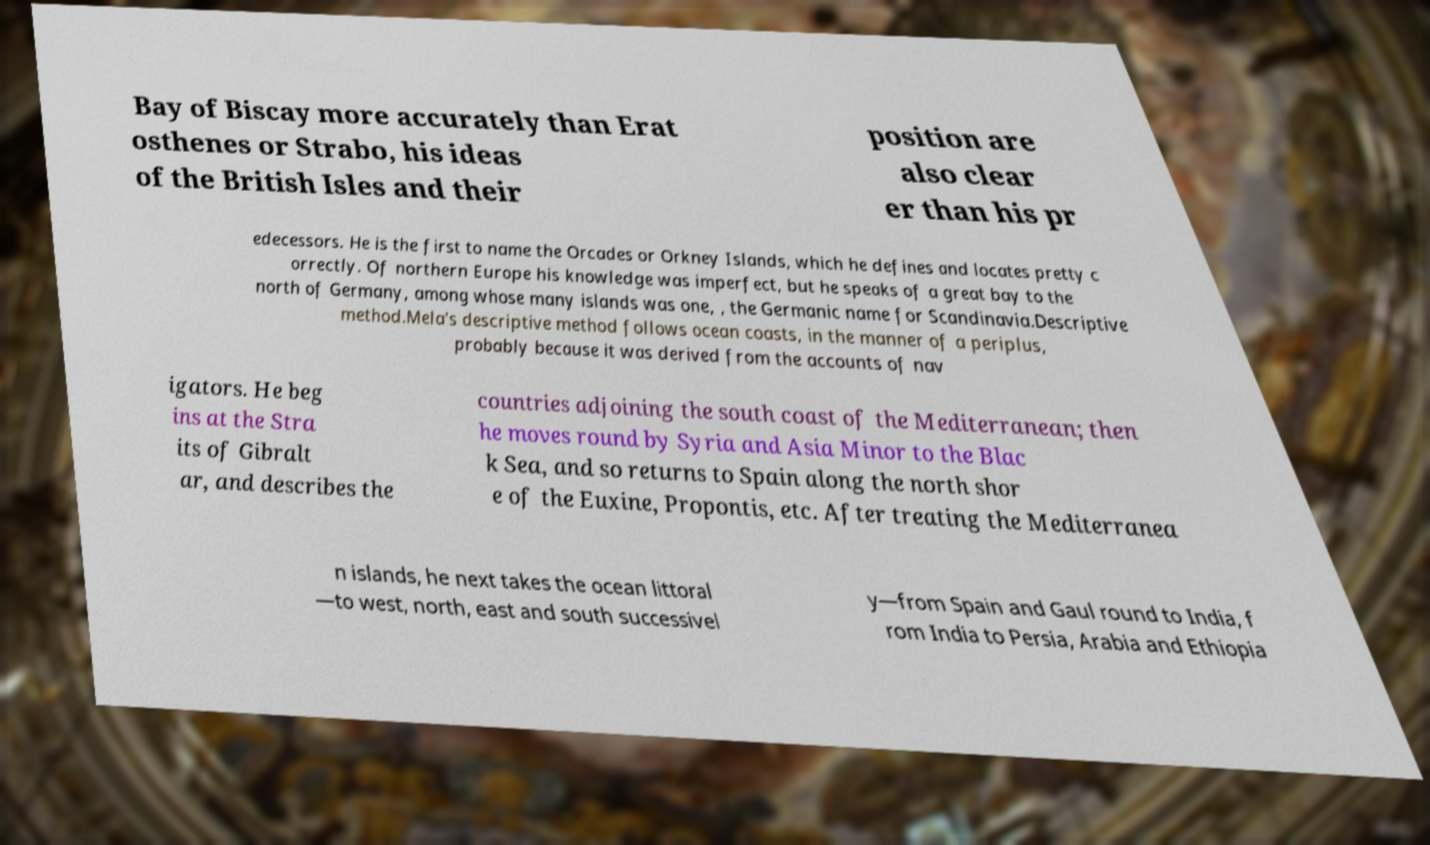Could you extract and type out the text from this image? Bay of Biscay more accurately than Erat osthenes or Strabo, his ideas of the British Isles and their position are also clear er than his pr edecessors. He is the first to name the Orcades or Orkney Islands, which he defines and locates pretty c orrectly. Of northern Europe his knowledge was imperfect, but he speaks of a great bay to the north of Germany, among whose many islands was one, , the Germanic name for Scandinavia.Descriptive method.Mela's descriptive method follows ocean coasts, in the manner of a periplus, probably because it was derived from the accounts of nav igators. He beg ins at the Stra its of Gibralt ar, and describes the countries adjoining the south coast of the Mediterranean; then he moves round by Syria and Asia Minor to the Blac k Sea, and so returns to Spain along the north shor e of the Euxine, Propontis, etc. After treating the Mediterranea n islands, he next takes the ocean littoral —to west, north, east and south successivel y—from Spain and Gaul round to India, f rom India to Persia, Arabia and Ethiopia 